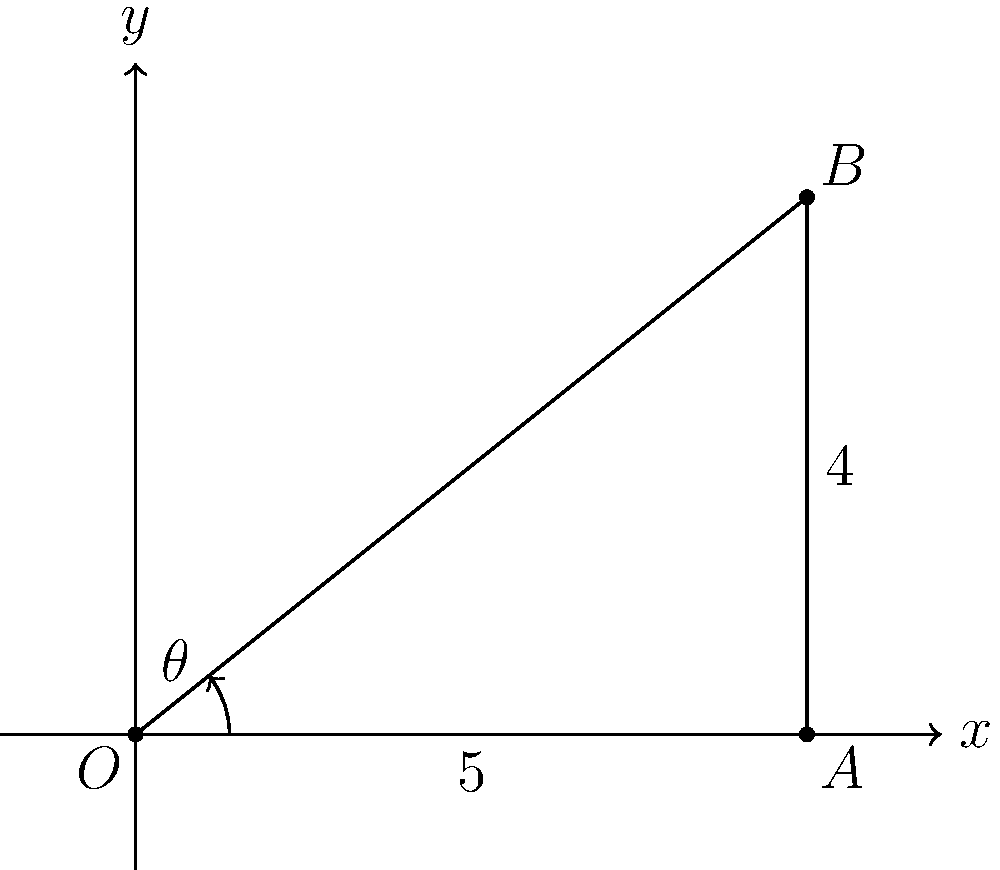In a contemporary jazz dance routine, a dancer extends their leg to create a right triangle with the floor. If the horizontal distance from their supporting foot to the tip of their extended foot is 5 units, and the height of their extended foot is 4 units, what is the angle $\theta$ (in degrees) of their leg extension from the floor? Use the arctangent function and round your answer to the nearest degree. To solve this problem, we'll follow these steps:

1) First, we need to identify the right triangle formed by the dancer's leg extension. In this case:
   - The base of the triangle (horizontal distance) is 5 units
   - The height of the triangle (vertical distance) is 4 units

2) The angle $\theta$ we're looking for is the angle between the floor (base of the triangle) and the hypotenuse (the dancer's extended leg).

3) We can find this angle using the arctangent function (also written as $\tan^{-1}$ or $\arctan$). The arctangent function gives us the angle when we know the opposite and adjacent sides of a right triangle.

4) In this case:
   - Opposite side (height) = 4
   - Adjacent side (base) = 5

5) The formula to use is:
   $\theta = \arctan(\frac{\text{opposite}}{\text{adjacent}}) = \arctan(\frac{4}{5})$

6) Using a calculator or computer:
   $\theta = \arctan(\frac{4}{5}) \approx 0.6747 \text{ radians}$

7) To convert radians to degrees, we multiply by $\frac{180}{\pi}$:
   $\theta \approx 0.6747 \times \frac{180}{\pi} \approx 38.66 \text{ degrees}$

8) Rounding to the nearest degree:
   $\theta \approx 39 \text{ degrees}$

Therefore, the angle of the dancer's leg extension from the floor is approximately 39 degrees.
Answer: 39° 